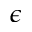Convert formula to latex. <formula><loc_0><loc_0><loc_500><loc_500>\epsilon</formula> 